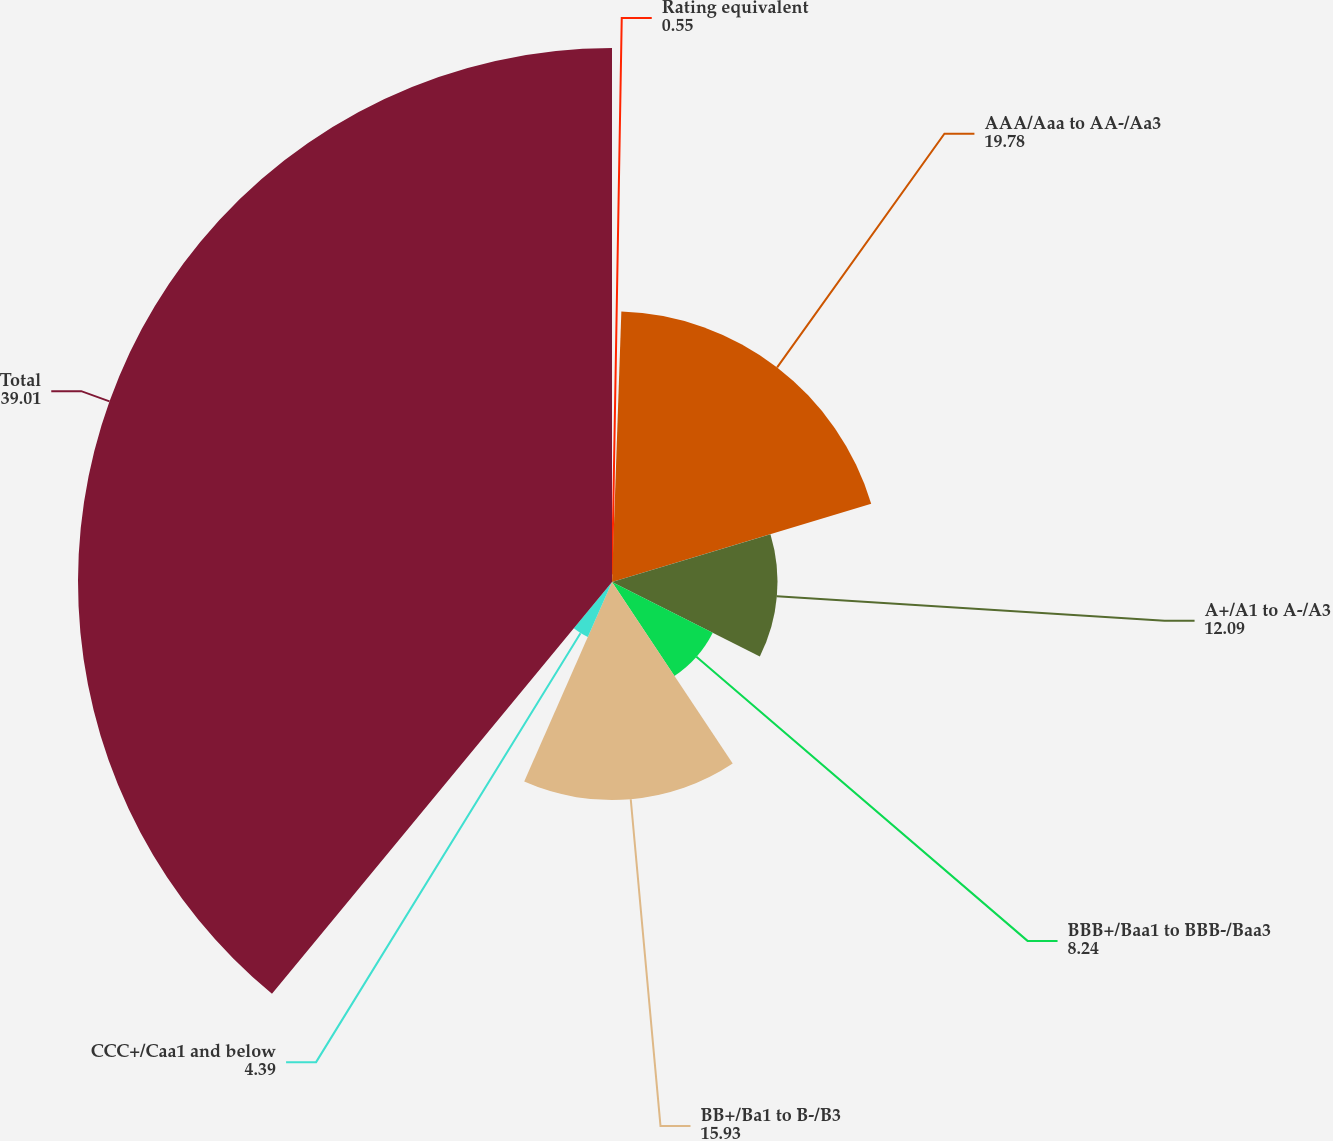Convert chart. <chart><loc_0><loc_0><loc_500><loc_500><pie_chart><fcel>Rating equivalent<fcel>AAA/Aaa to AA-/Aa3<fcel>A+/A1 to A-/A3<fcel>BBB+/Baa1 to BBB-/Baa3<fcel>BB+/Ba1 to B-/B3<fcel>CCC+/Caa1 and below<fcel>Total<nl><fcel>0.55%<fcel>19.78%<fcel>12.09%<fcel>8.24%<fcel>15.93%<fcel>4.39%<fcel>39.01%<nl></chart> 